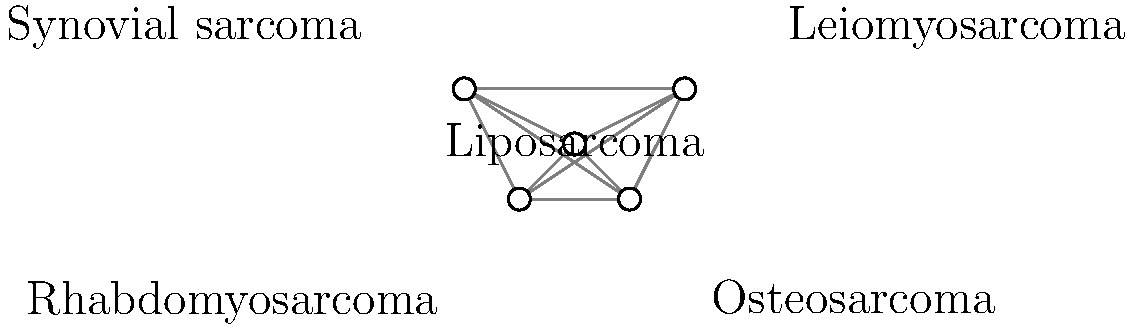Based on the network diagram of sarcoma types, which sarcoma is most likely to show cross-striations in histological images and is associated with skeletal muscle differentiation? To answer this question, we need to consider the characteristics of each sarcoma type represented in the network:

1. Liposarcoma: Originates from adipose (fat) tissue, typically showing lipoblasts.
2. Leiomyosarcoma: Arises from smooth muscle cells, showing spindle cells with cigar-shaped nuclei.
3. Osteosarcoma: Produces osteoid (immature bone matrix) and is associated with bone formation.
4. Rhabdomyosarcoma: Derived from skeletal muscle precursor cells, showing cross-striations.
5. Synovial sarcoma: Typically biphasic with epithelial and spindle cell components.

Among these options, rhabdomyosarcoma is the only sarcoma type that is specifically associated with skeletal muscle differentiation. The key characteristic of rhabdomyosarcoma in histological images is the presence of cross-striations, which are visible striped patterns within the tumor cells. These cross-striations represent the organized arrangement of actin and myosin filaments, similar to what is seen in normal skeletal muscle fibers.

The cross-striations are a unique feature of rhabdomyosarcoma among soft tissue sarcomas and serve as an important diagnostic criterion. They can be observed using light microscopy with special stains or immunohistochemistry techniques that highlight muscle-specific proteins such as desmin, myogenin, or MyoD1.
Answer: Rhabdomyosarcoma 